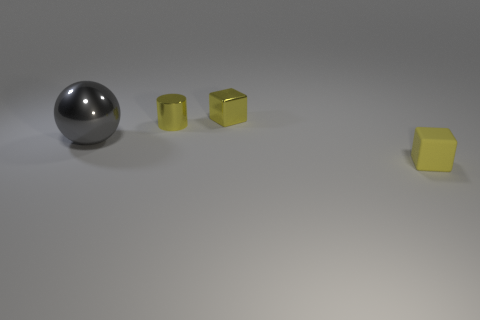What number of big objects are either metal blocks or red spheres?
Your response must be concise. 0. The large thing has what color?
Keep it short and to the point. Gray. What shape is the gray object that is behind the small cube that is in front of the gray object?
Your answer should be compact. Sphere. Is there a small yellow cylinder made of the same material as the ball?
Provide a short and direct response. Yes. There is a yellow cube behind the ball; is it the same size as the yellow matte object?
Provide a short and direct response. Yes. What number of green things are either cylinders or tiny rubber things?
Your answer should be compact. 0. There is a thing that is to the right of the tiny metal block; what material is it?
Your answer should be compact. Rubber. How many yellow metallic things are behind the block to the left of the tiny yellow matte cube?
Provide a short and direct response. 0. What number of yellow rubber objects have the same shape as the gray metal thing?
Ensure brevity in your answer.  0. How many small cyan metallic cubes are there?
Keep it short and to the point. 0. 